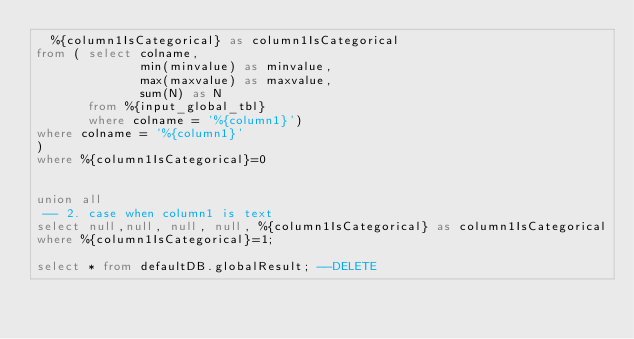<code> <loc_0><loc_0><loc_500><loc_500><_SQL_>	%{column1IsCategorical} as column1IsCategorical
from ( select colname,
              min(minvalue) as minvalue,
              max(maxvalue) as maxvalue,
              sum(N) as N
       from %{input_global_tbl}
       where colname = '%{column1}') 
where colname = '%{column1}'
)
where %{column1IsCategorical}=0


union all 
 -- 2. case when column1 is text 
select null,null, null, null, %{column1IsCategorical} as column1IsCategorical
where %{column1IsCategorical}=1;

select * from defaultDB.globalResult; --DELETE 
</code> 